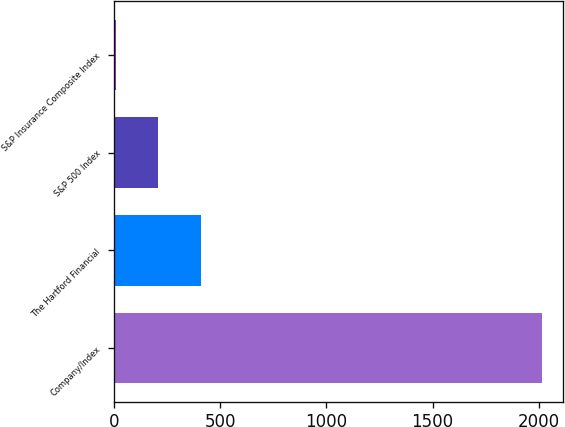Convert chart. <chart><loc_0><loc_0><loc_500><loc_500><bar_chart><fcel>Company/Index<fcel>The Hartford Financial<fcel>S&P 500 Index<fcel>S&P Insurance Composite Index<nl><fcel>2014<fcel>409.43<fcel>208.86<fcel>8.29<nl></chart> 